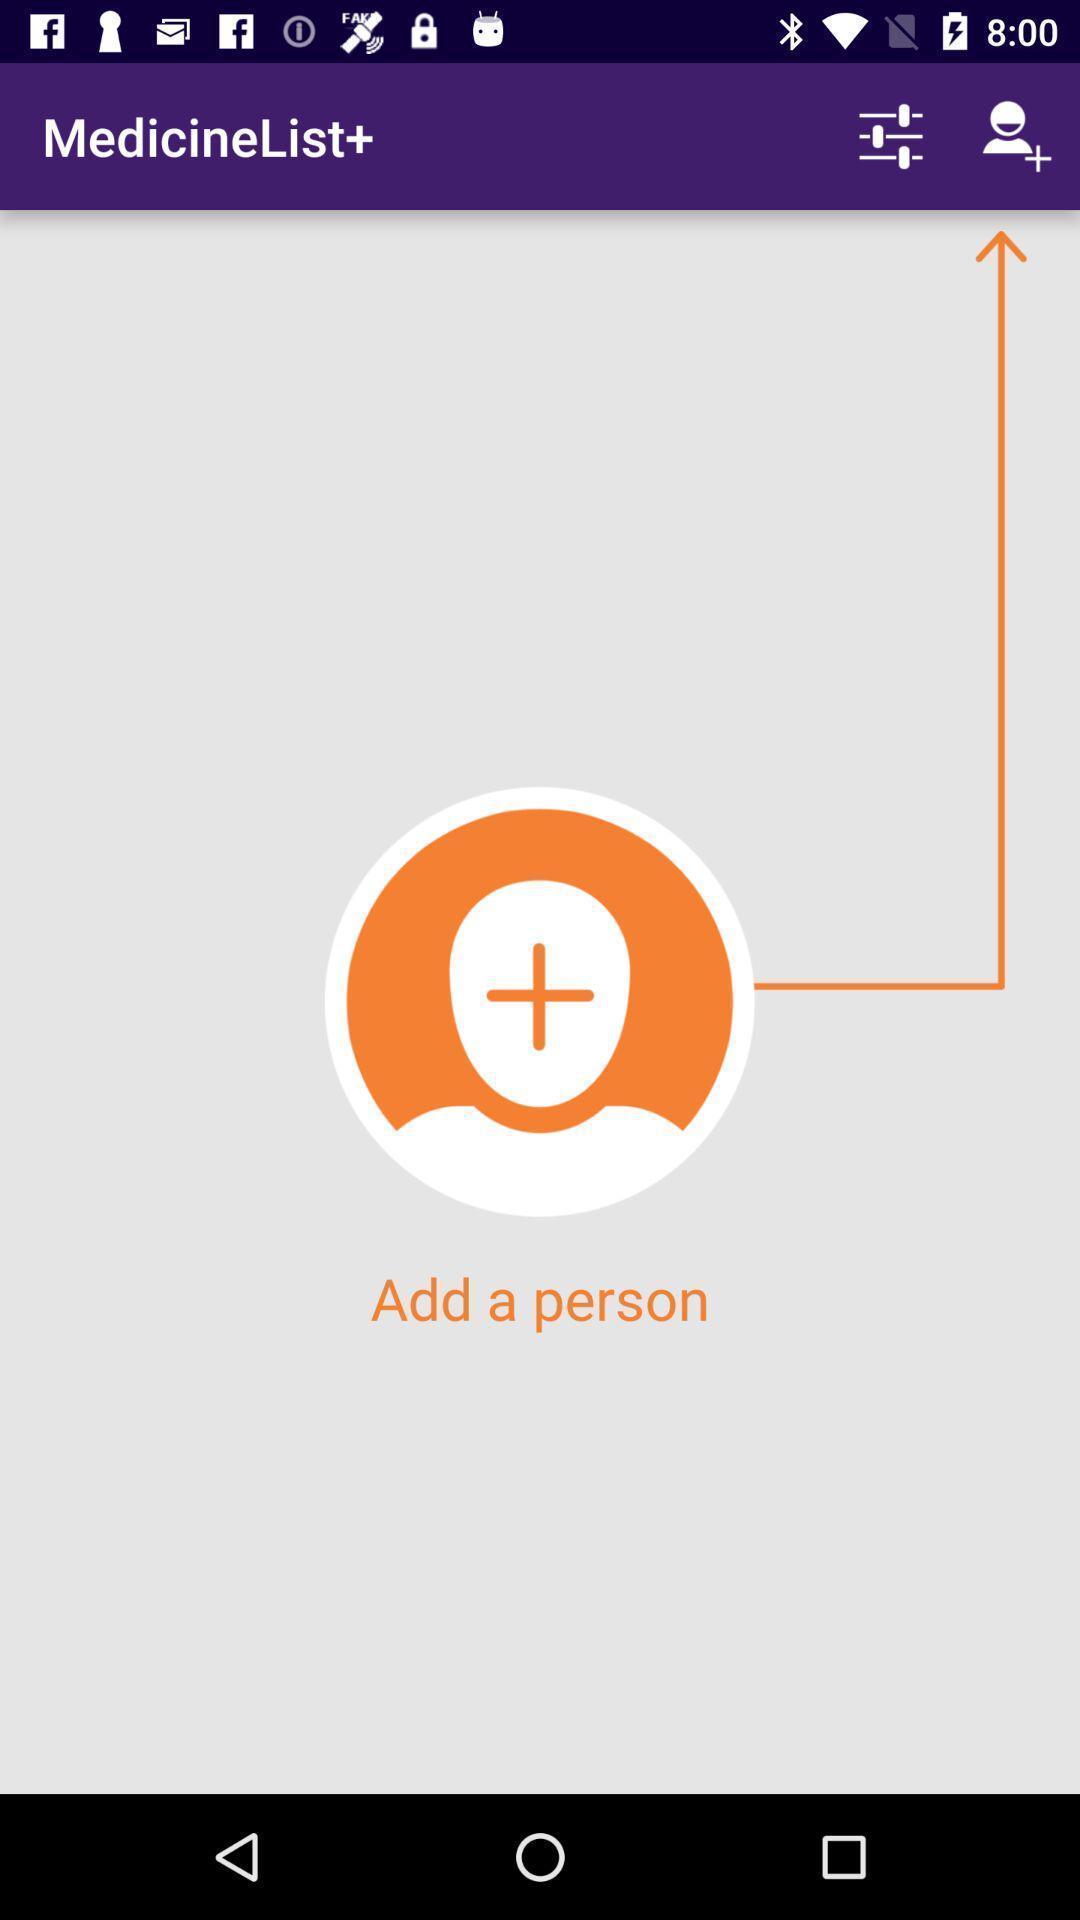Give me a summary of this screen capture. Page displaying to add a person in the app. 